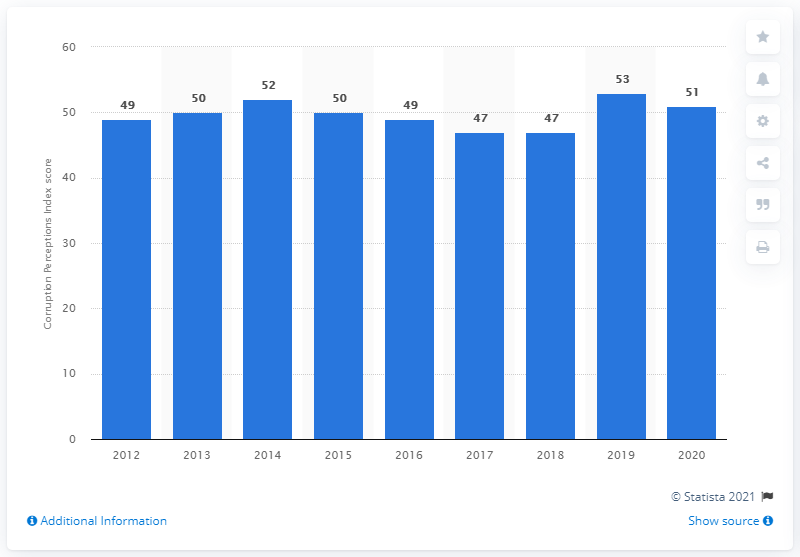Draw attention to some important aspects in this diagram. According to the Corruption Perception Index 2020, Malaysia's score was 51, indicating a moderate level of corruption in the country. 